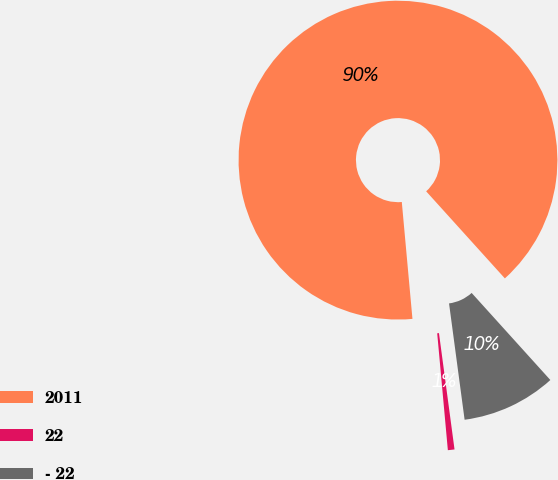Convert chart to OTSL. <chart><loc_0><loc_0><loc_500><loc_500><pie_chart><fcel>2011<fcel>22<fcel>- 22<nl><fcel>89.75%<fcel>0.67%<fcel>9.58%<nl></chart> 